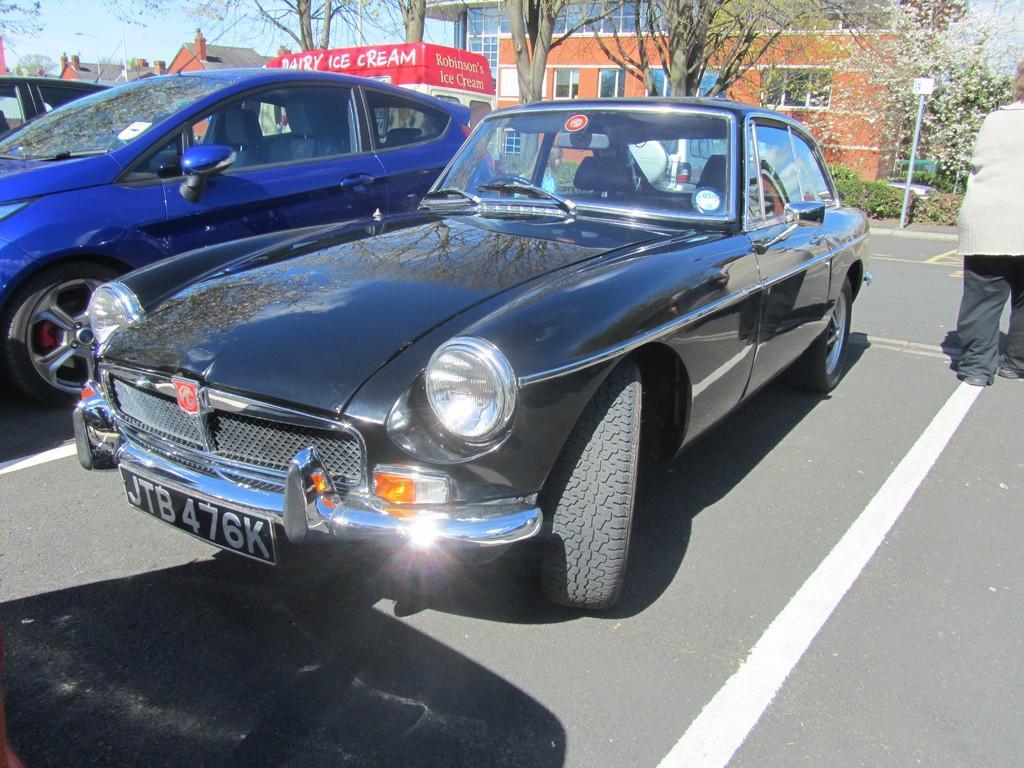Describe this image in one or two sentences. In this image we can see few cars. Behind the cars we can see the buildings, trees and a banner with text. On the right side, we can see a person, pole and plants. At the top we can see the sky. 